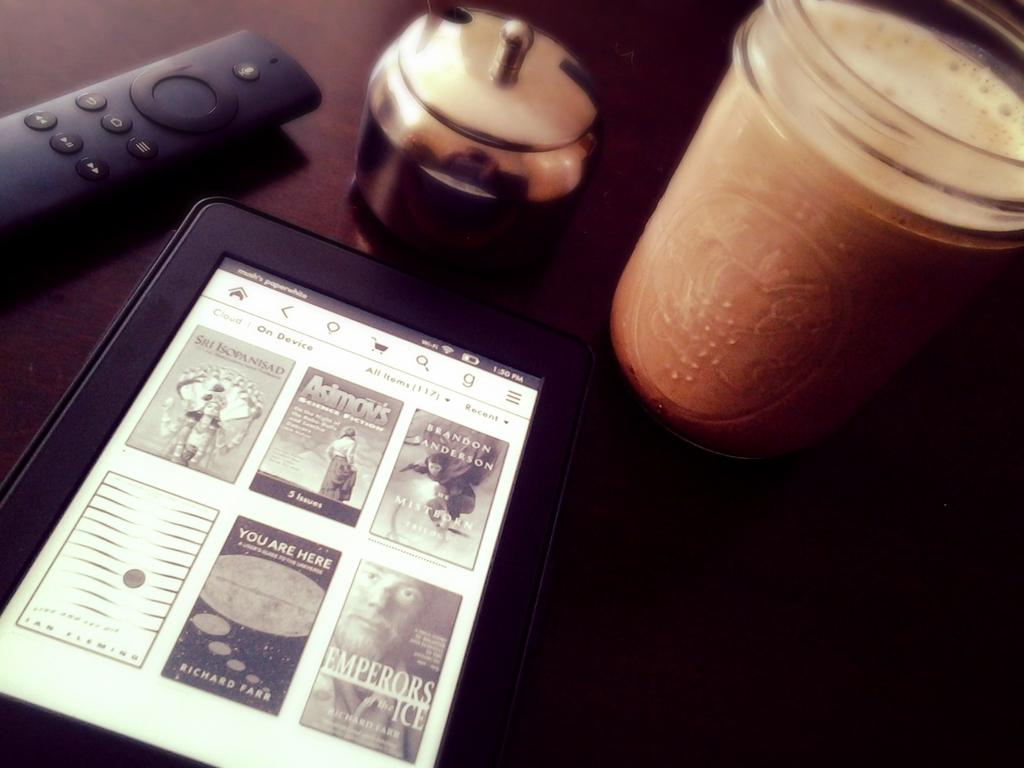Provide a one-sentence caption for the provided image. A Kindle is open and has a number of books displayed including one titled Emperors Ice. 